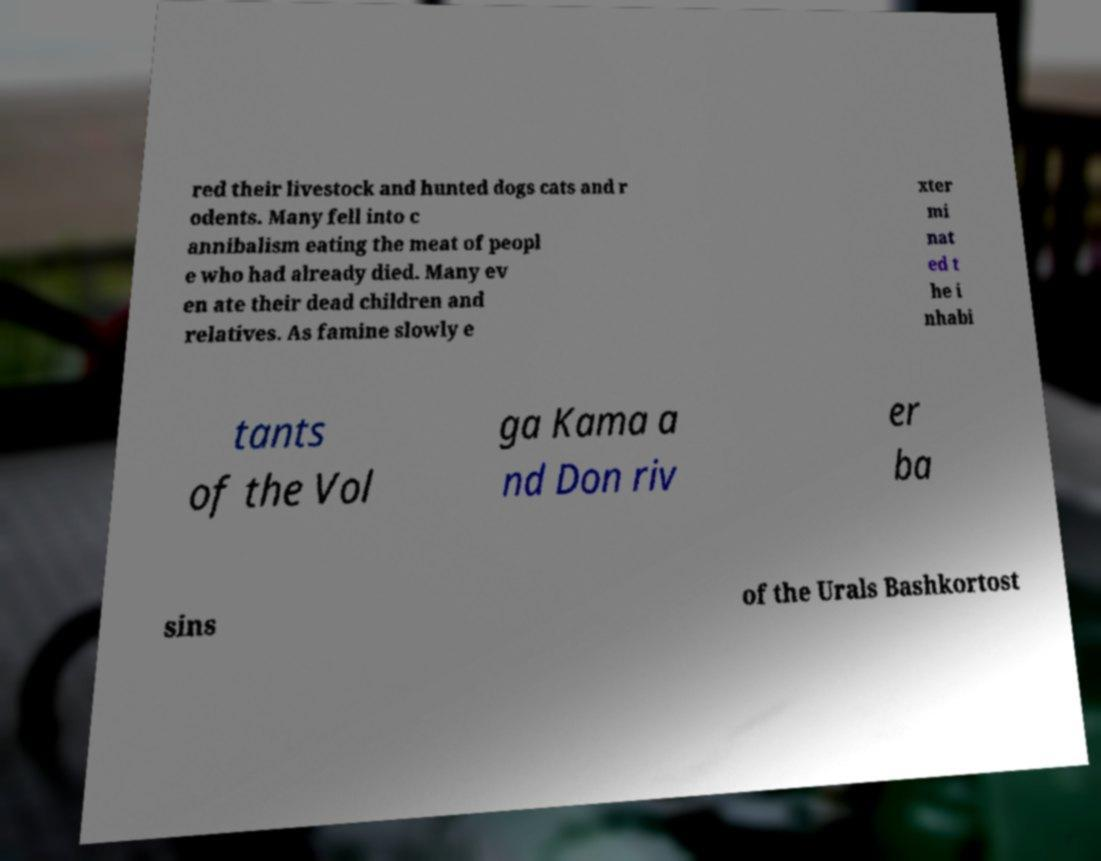Please read and relay the text visible in this image. What does it say? red their livestock and hunted dogs cats and r odents. Many fell into c annibalism eating the meat of peopl e who had already died. Many ev en ate their dead children and relatives. As famine slowly e xter mi nat ed t he i nhabi tants of the Vol ga Kama a nd Don riv er ba sins of the Urals Bashkortost 